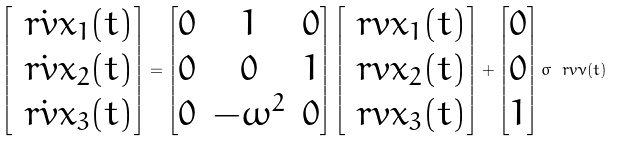Convert formula to latex. <formula><loc_0><loc_0><loc_500><loc_500>\begin{bmatrix} \dot { \ r v { x } } _ { 1 } ( t ) \\ \dot { \ r v { x } } _ { 2 } ( t ) \\ \dot { \ r v { x } } _ { 3 } ( t ) \end{bmatrix} = \begin{bmatrix} 0 & 1 & 0 \\ 0 & 0 & 1 \\ 0 & - \omega ^ { 2 } & 0 \end{bmatrix} \begin{bmatrix} \ r v { x } _ { 1 } ( t ) \\ \ r v { x } _ { 2 } ( t ) \\ \ r v { x } _ { 3 } ( t ) \end{bmatrix} + \begin{bmatrix} 0 \\ 0 \\ 1 \end{bmatrix} \sigma \ r v { \nu } ( t )</formula> 